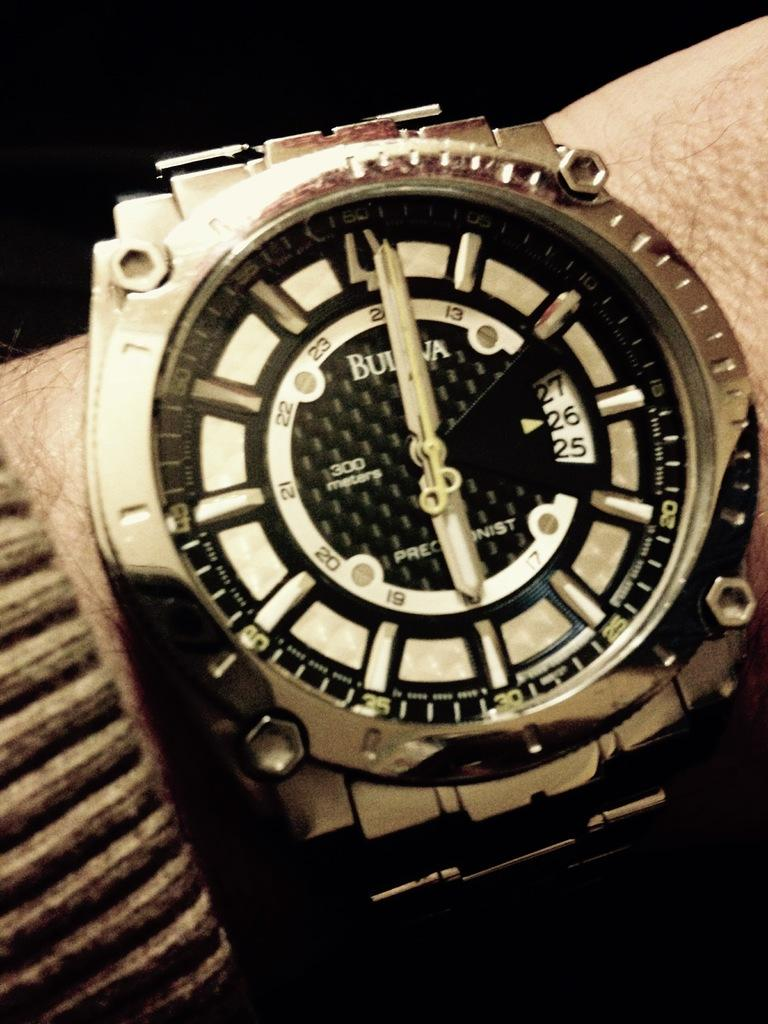What object can be seen on the person's hand in the image? There is a wrist watch on the hand of a person in the image. Can you describe the wrist watch in the image? The wrist watch is the main object visible on the person's hand. What color is the paint used to create the wrist watch in the image? There is no paint used to create the wrist watch in the image, as it is a real wrist watch. 